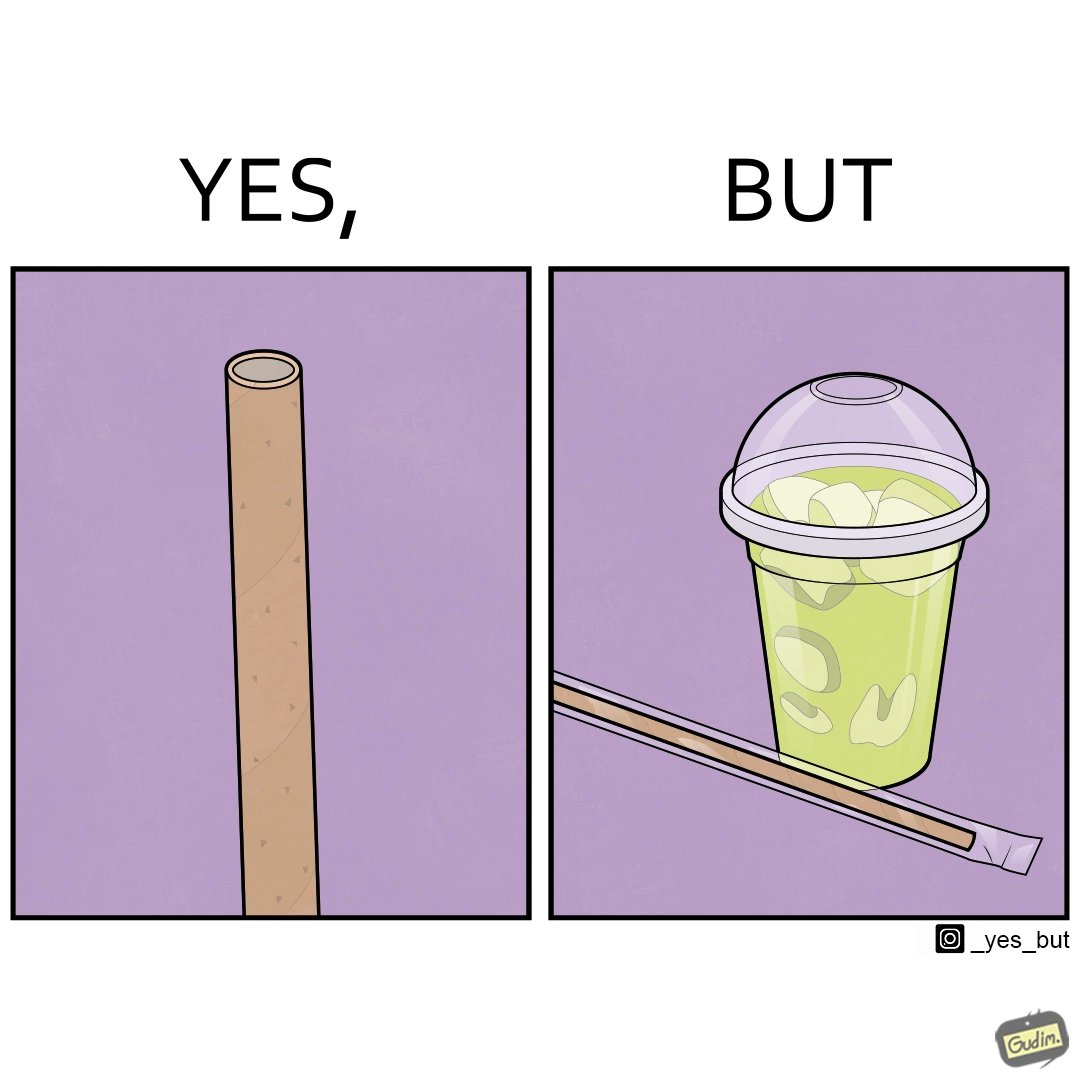Compare the left and right sides of this image. In the left part of the image: It is a paper straw In the right part of the image: It is paper straw in a plastic covering and a soft drink in a plastic cup 